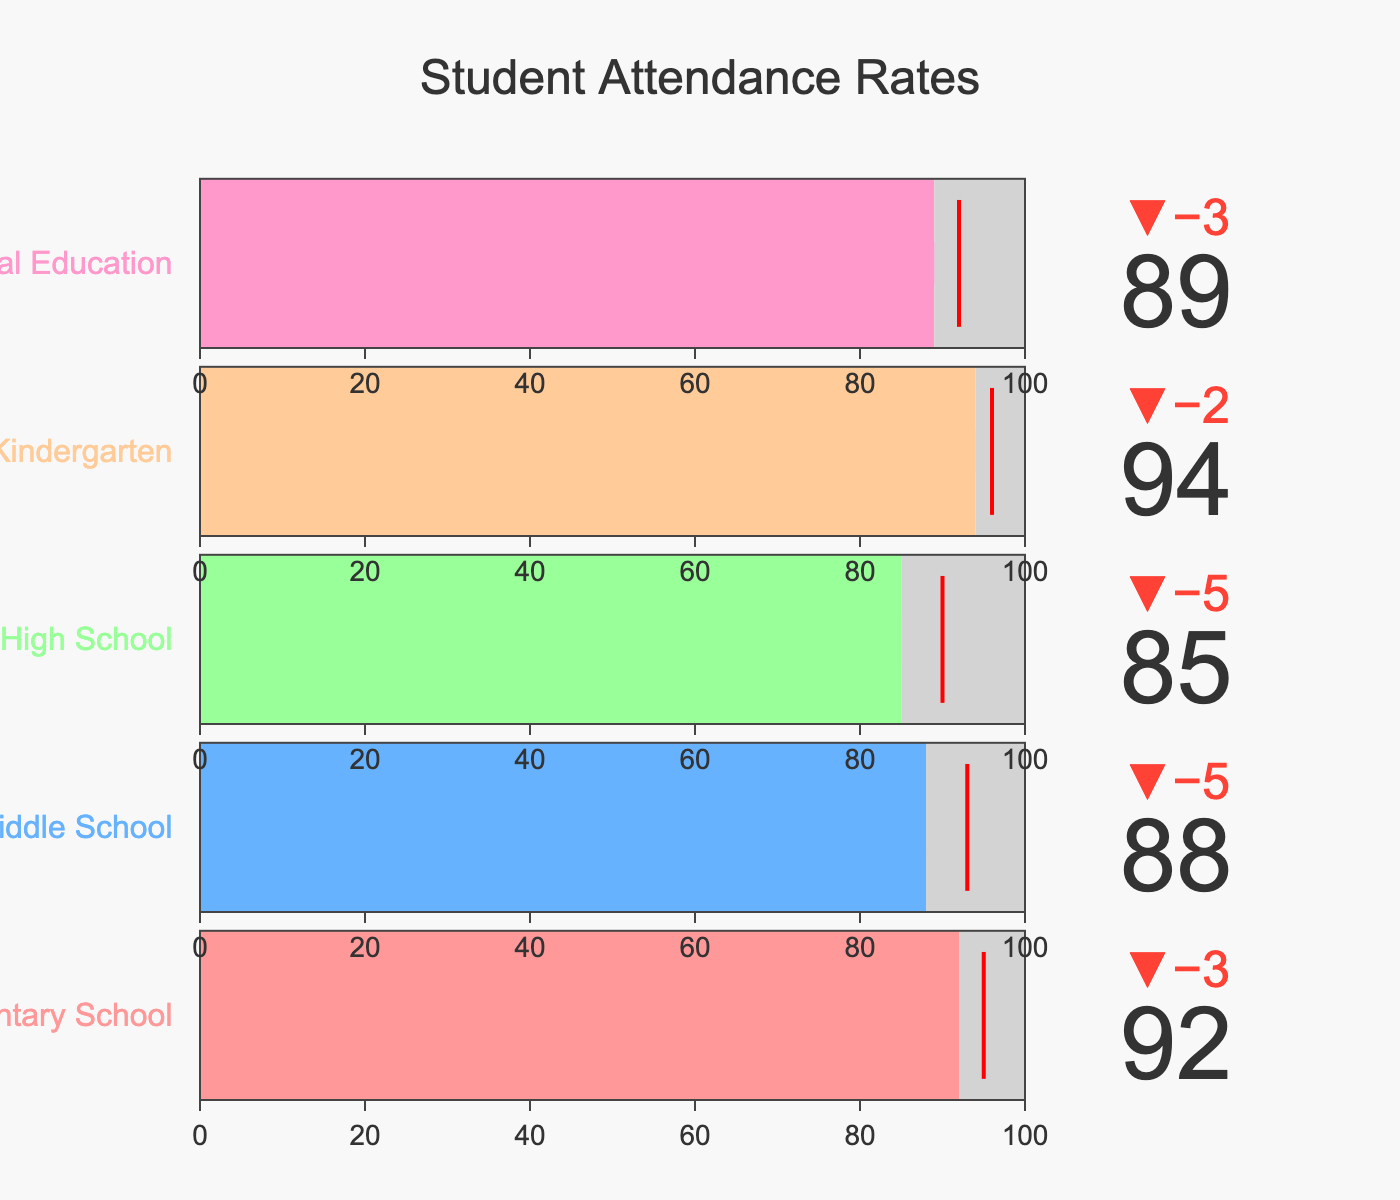How many grades are represented in the figure? The figure shows five different grade levels indicated by their titles.
Answer: 5 What is the title of the figure? The title can be found at the top center of the figure.
Answer: Student Attendance Rates Which grade level has the highest actual attendance? By comparing the actual attendance values for all grades, Kindergarten has the highest value at 94.
Answer: Kindergarten Which grade level has the lowest attendance difference from the target? The difference between actual and target attendance is smallest for Special Education, with a difference of 3 (92-89).
Answer: Special Education What is the overall range of attendance shown by the bullet charts? The range is from the lowest maximum attendance (85) to the highest maximum attendance (100).
Answer: 85 to 100 What is the average actual attendance across all grades? Sum all actual attendance values (92 + 88 + 85 + 94 + 89) and divide by the number of grades (5). (448 / 5)
Answer: 89.6 Which grade level has actual attendance below the target attendance? By examining attendance levels, Elementary School, Middle School, High School, and Special Education are below their target.
Answer: Elementary School, Middle School, High School, Special Education What color represents Kindergarten? The bar for Kindergarten is visually distinct by its specific color in the figure, which is pinkish.
Answer: Pinkish Which grade level exceeds its actual attendance compared to the maximum attendance? Upon comparing actual values to maximum (100) in the figure, none of the grades exceed the maximum attendance.
Answer: None How much below target is High School attendance? Subtract the actual attendance (85) from target attendance (90) for High School. (90 - 85)
Answer: 5 